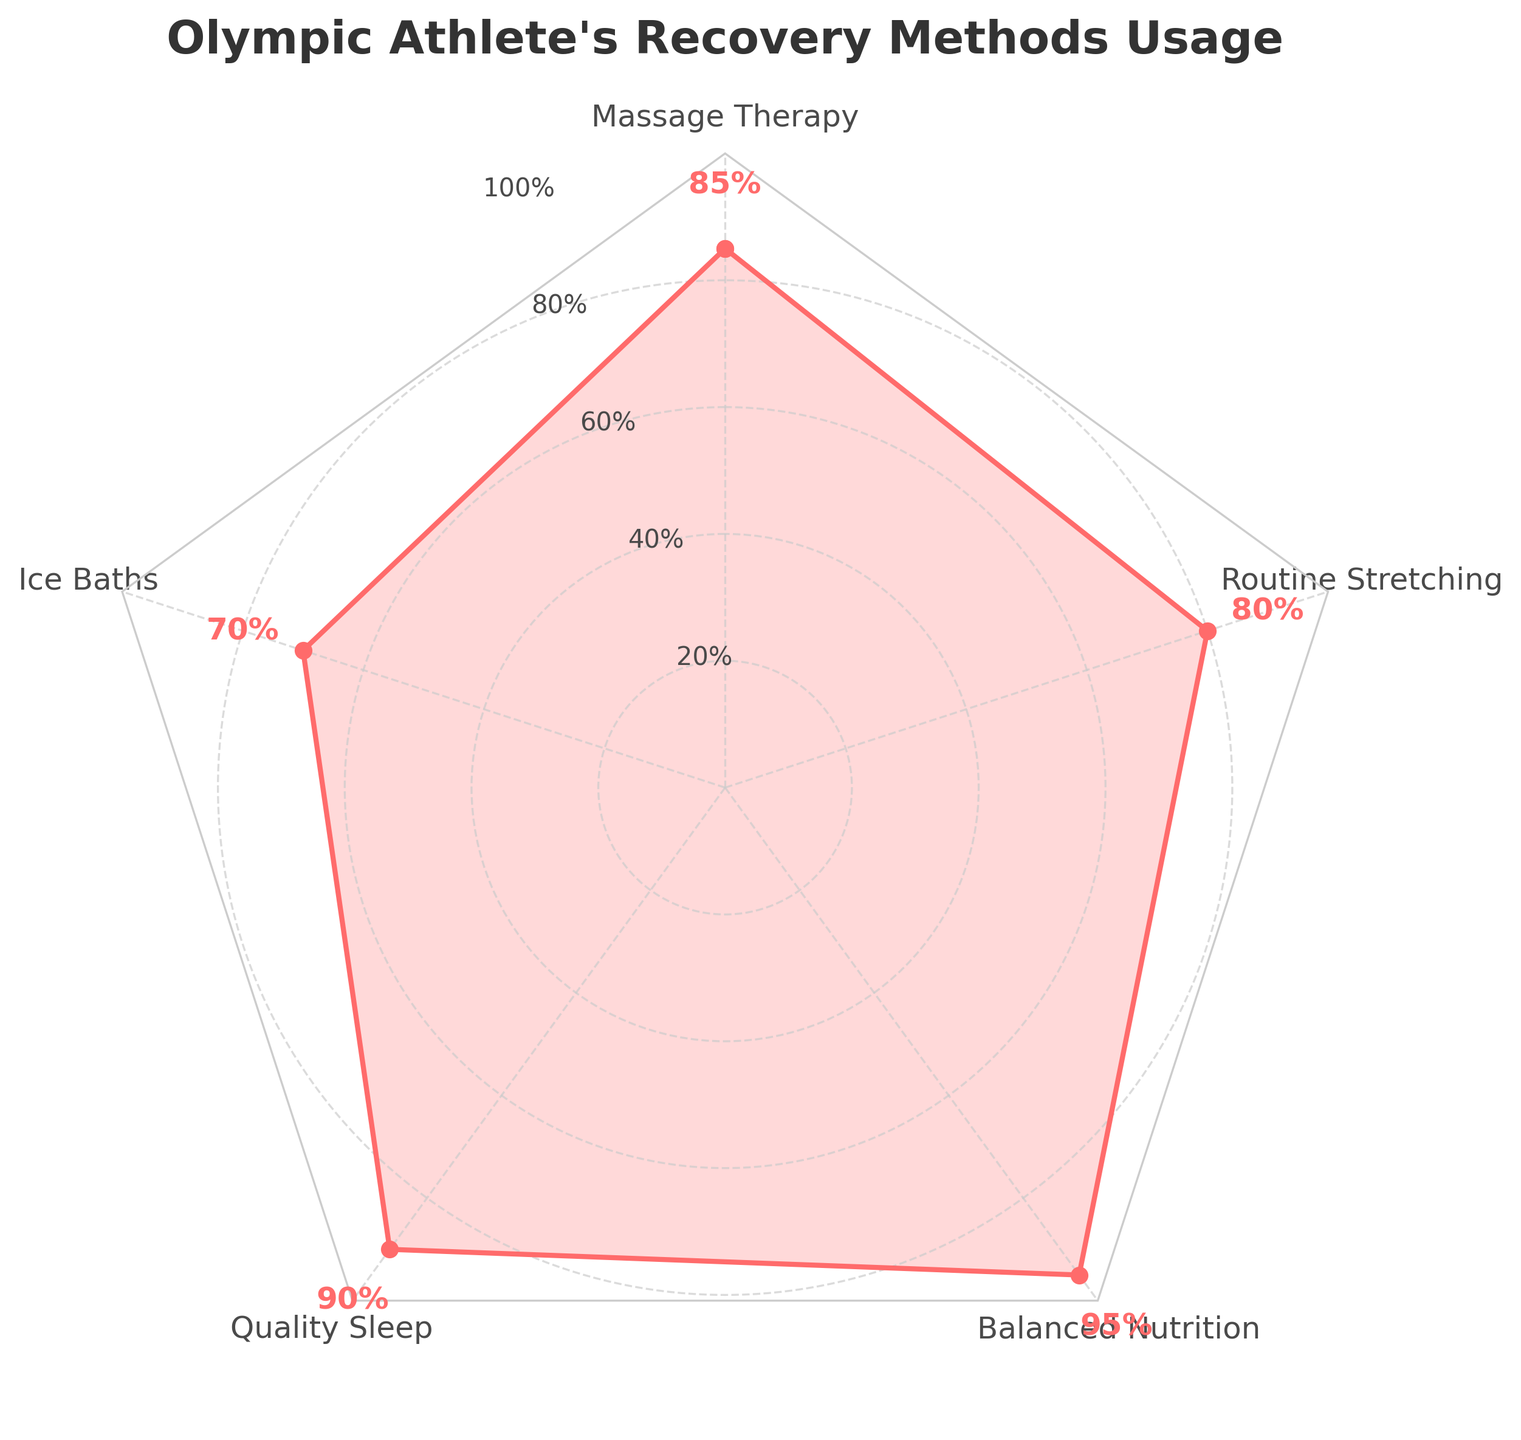What is the title of the radar chart? The title of the chart is displayed in bold at the top of the figure. It is "Olympic Athlete's Recovery Methods Usage".
Answer: Olympic Athlete's Recovery Methods Usage What are the five recovery methods shown in the radar chart? The radar chart displays five recovery methods as labels around the chart: Massage Therapy, Ice Baths, Quality Sleep, Balanced Nutrition, and Routine Stretching.
Answer: Massage Therapy, Ice Baths, Quality Sleep, Balanced Nutrition, Routine Stretching Which recovery method has the highest usage percentage? To determine the highest usage percentage, locate the highest value in the chart. The highest percentage is 95% for Balanced Nutrition.
Answer: Balanced Nutrition Which recovery method has the lowest usage percentage? To find the lowest usage percentage, look for the smallest value displayed in the chart. The lowest percentage is 70% for Ice Baths.
Answer: Ice Baths What is the average usage percentage across all recovery methods? To calculate the average, sum up all the usage percentages (85 + 70 + 90 + 95 + 80 = 420) and divide by the number of methods (5). The result is 420/5 = 84.
Answer: 84 How much higher is the usage percentage of Balanced Nutrition compared to Ice Baths? Subtract the usage percentage of Ice Baths (70%) from Balanced Nutrition (95%), which gives 95% - 70% = 25%.
Answer: 25% Which recovery method has a usage percentage closest to 80%? Compare all the usage percentages to 80%. The closest percentage is for Routine Stretching, which is exactly 80%.
Answer: Routine Stretching Rank the recovery methods from highest to lowest usage percentage. List the usage percentages in descending order: Balanced Nutrition (95%), Quality Sleep (90%), Massage Therapy (85%), Routine Stretching (80%), Ice Baths (70%).
Answer: Balanced Nutrition, Quality Sleep, Massage Therapy, Routine Stretching, Ice Baths Are more than half of the recovery methods used by 80% or more percent of the athletes? There are five recovery methods. Identify those with a usage percentage of 80% or more: Massage Therapy (85%), Quality Sleep (90%), Balanced Nutrition (95%), and Routine Stretching (80%). There are 4 such methods out of 5. Since 4 is more than half of 5, the answer is yes.
Answer: Yes 